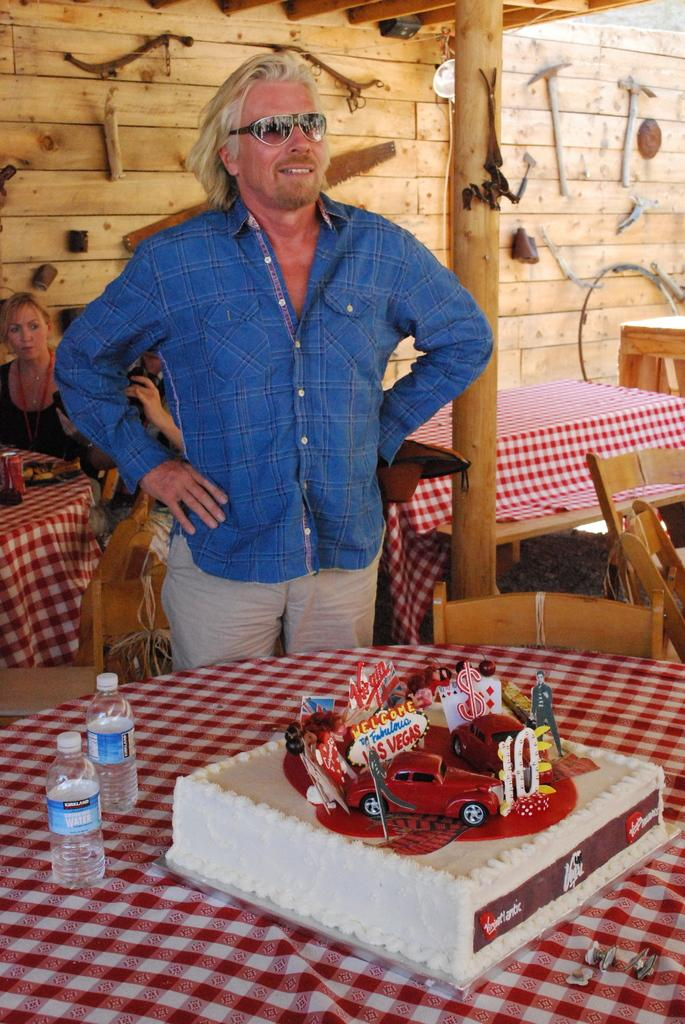What is the man in the image doing? The man is standing in the image. What object can be seen in the image besides the man? There is a table in the image. What is on the table in the image? There is a cake on the table. Who else is present in the image besides the man? There is a group of people sitting in the image. What is visible in the background of the image? There is a wall visible in the image. What type of cart is being used to transport the cake in the image? There is no cart present in the image; the cake is on a table. 